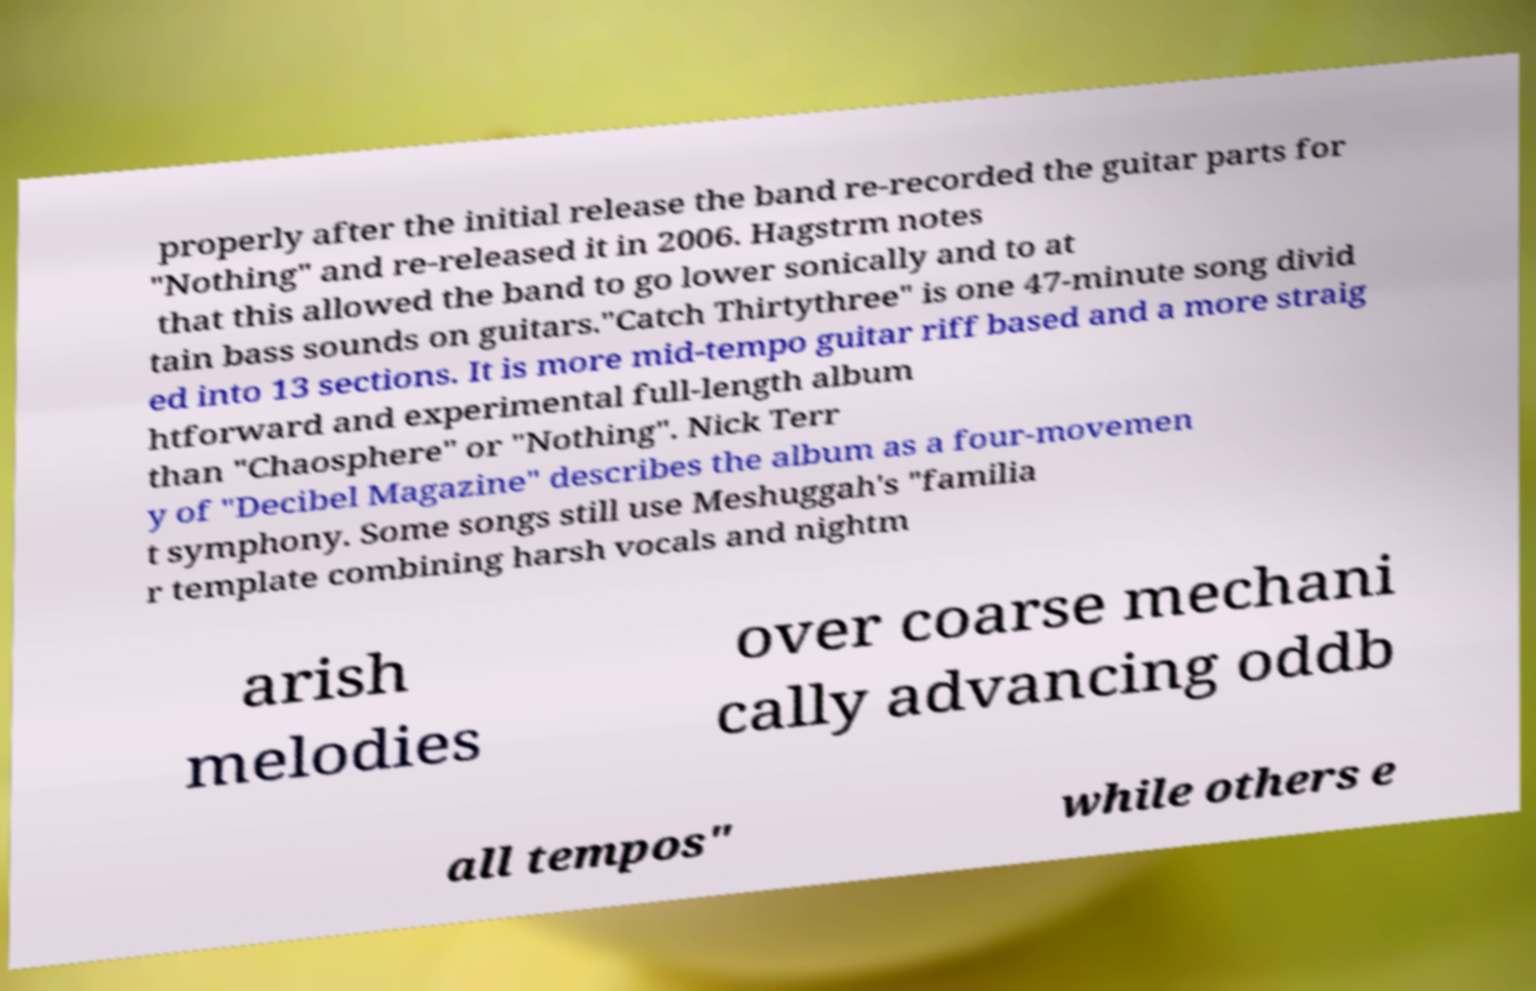What messages or text are displayed in this image? I need them in a readable, typed format. properly after the initial release the band re-recorded the guitar parts for "Nothing" and re-released it in 2006. Hagstrm notes that this allowed the band to go lower sonically and to at tain bass sounds on guitars."Catch Thirtythree" is one 47-minute song divid ed into 13 sections. It is more mid-tempo guitar riff based and a more straig htforward and experimental full-length album than "Chaosphere" or "Nothing". Nick Terr y of "Decibel Magazine" describes the album as a four-movemen t symphony. Some songs still use Meshuggah's "familia r template combining harsh vocals and nightm arish melodies over coarse mechani cally advancing oddb all tempos" while others e 